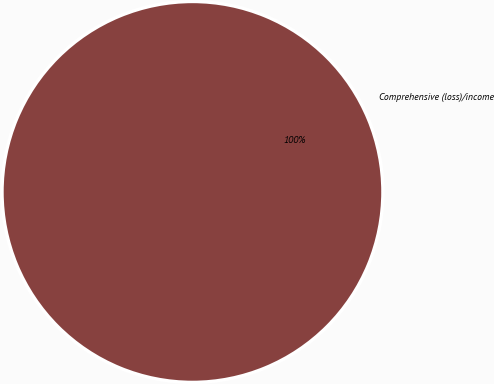Convert chart. <chart><loc_0><loc_0><loc_500><loc_500><pie_chart><fcel>Comprehensive (loss)/income<nl><fcel>100.0%<nl></chart> 